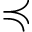Convert formula to latex. <formula><loc_0><loc_0><loc_500><loc_500>\prec c u r l y e q</formula> 